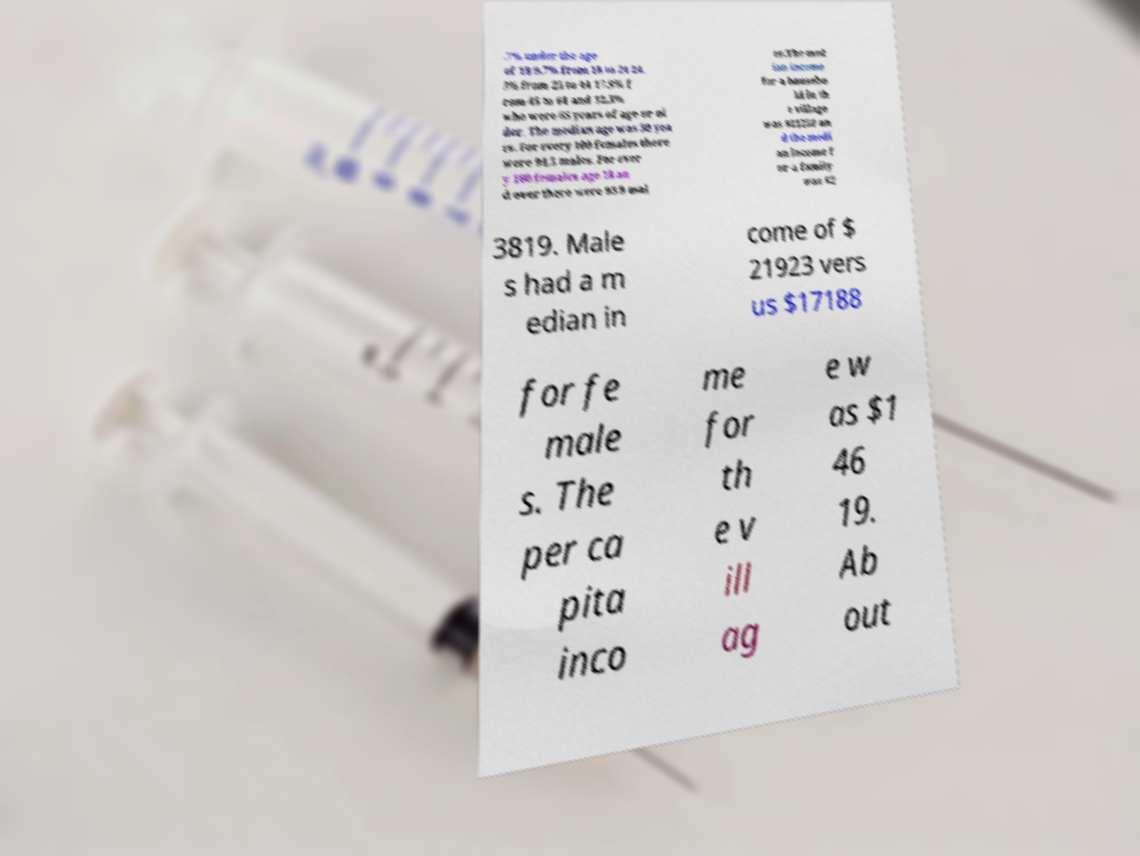Can you accurately transcribe the text from the provided image for me? .7% under the age of 18 9.7% from 18 to 24 24. 3% from 25 to 44 17.9% f rom 45 to 64 and 12.3% who were 65 years of age or ol der. The median age was 30 yea rs. For every 100 females there were 94.5 males. For ever y 100 females age 18 an d over there were 93.9 mal es.The med ian income for a househo ld in th e village was $21250 an d the medi an income f or a family was $2 3819. Male s had a m edian in come of $ 21923 vers us $17188 for fe male s. The per ca pita inco me for th e v ill ag e w as $1 46 19. Ab out 